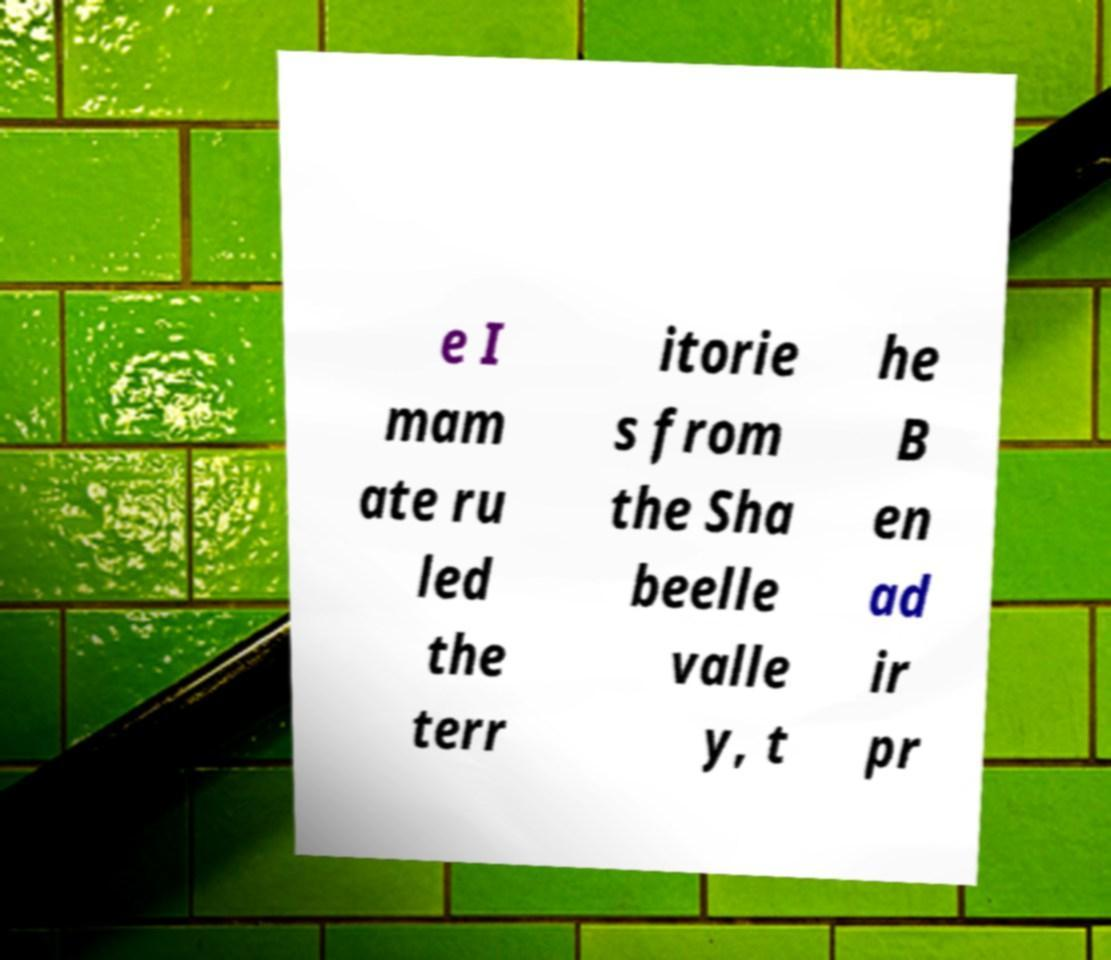Please identify and transcribe the text found in this image. e I mam ate ru led the terr itorie s from the Sha beelle valle y, t he B en ad ir pr 